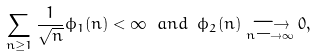Convert formula to latex. <formula><loc_0><loc_0><loc_500><loc_500>\sum _ { n \geq 1 } \frac { 1 } { \sqrt { n } } \phi _ { 1 } ( n ) < \infty \ a n d \ \phi _ { 2 } ( n ) \underset { n \longrightarrow \infty } { \longrightarrow } 0 ,</formula> 